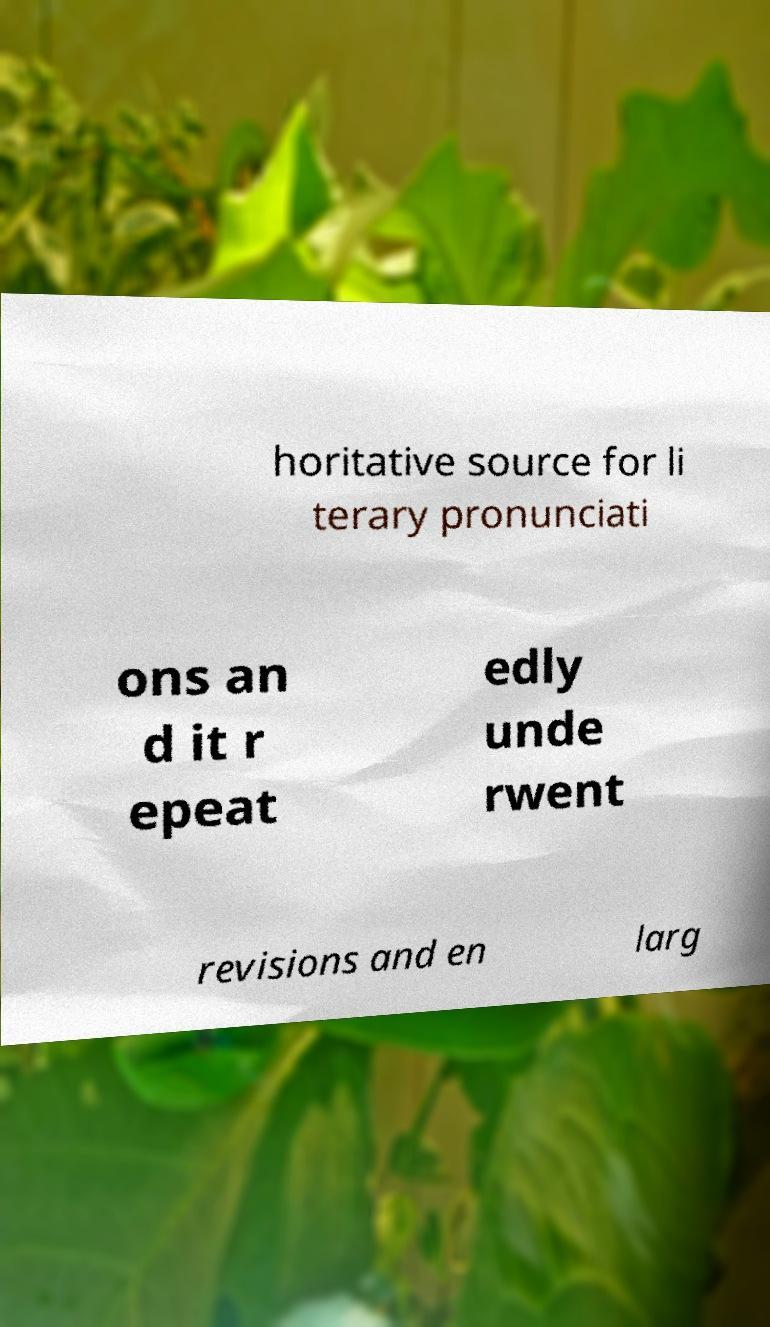Can you read and provide the text displayed in the image?This photo seems to have some interesting text. Can you extract and type it out for me? horitative source for li terary pronunciati ons an d it r epeat edly unde rwent revisions and en larg 